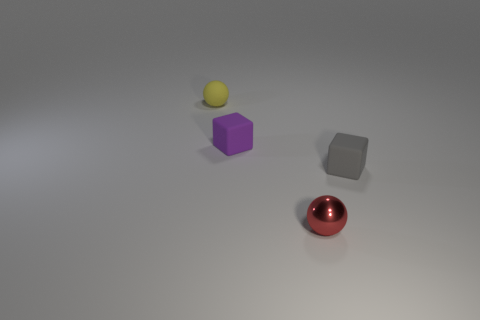Are there any things behind the yellow sphere that is left of the ball to the right of the tiny yellow sphere?
Provide a short and direct response. No. There is a thing to the right of the metallic object; does it have the same shape as the purple object?
Offer a very short reply. Yes. The tiny matte thing behind the block that is to the left of the tiny metal thing is what shape?
Give a very brief answer. Sphere. What is the size of the sphere that is right of the sphere that is behind the ball in front of the yellow object?
Offer a terse response. Small. What color is the other tiny thing that is the same shape as the small purple object?
Offer a very short reply. Gray. Is the size of the red sphere the same as the gray thing?
Your answer should be very brief. Yes. There is a small block that is on the right side of the tiny shiny object; what is its material?
Offer a very short reply. Rubber. Is the small purple thing the same shape as the tiny red thing?
Your answer should be compact. No. There is a shiny ball; are there any tiny purple cubes right of it?
Offer a very short reply. No. What number of objects are either small yellow matte balls or small red matte spheres?
Offer a terse response. 1. 